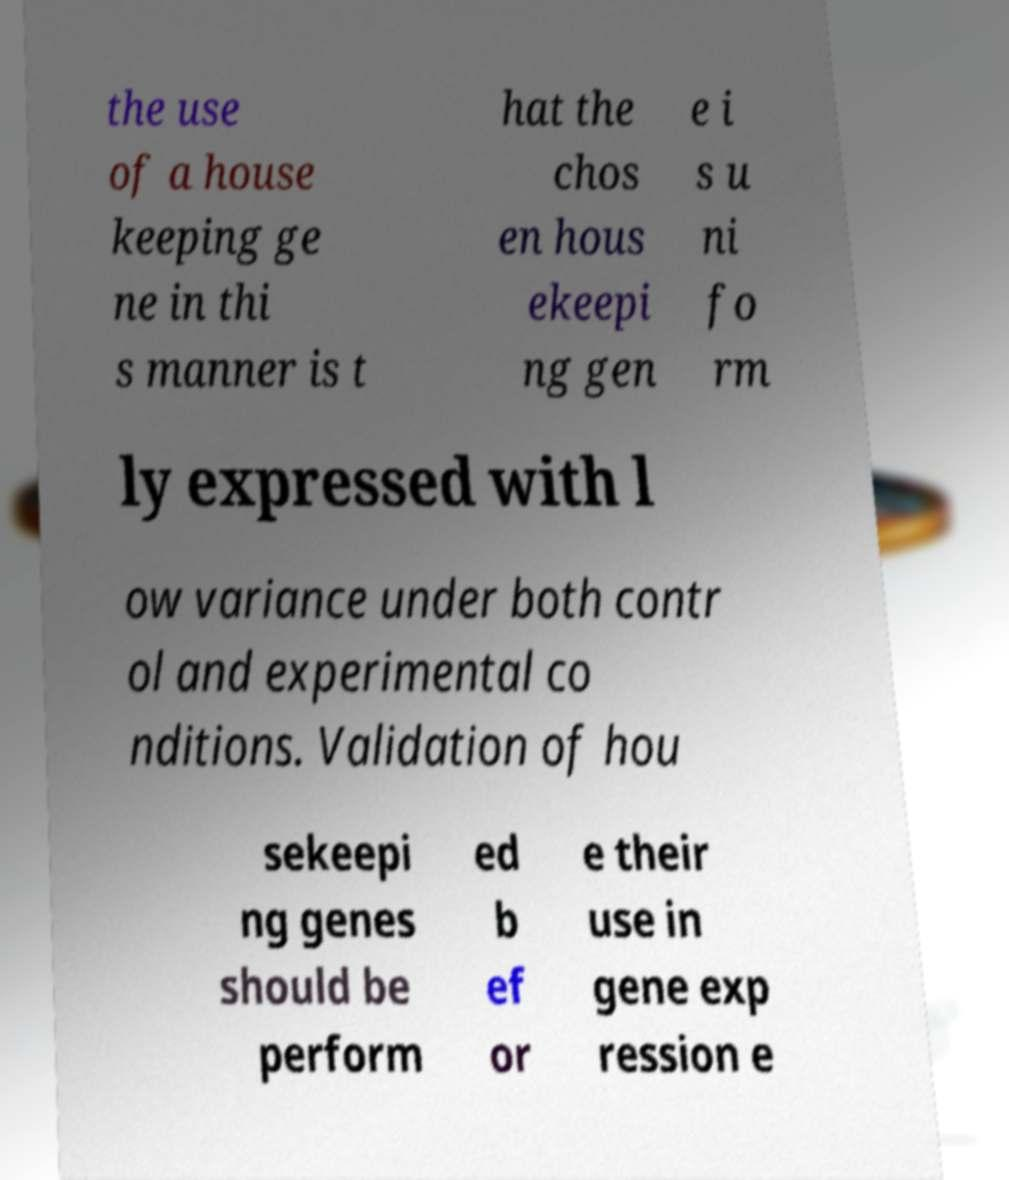Please identify and transcribe the text found in this image. the use of a house keeping ge ne in thi s manner is t hat the chos en hous ekeepi ng gen e i s u ni fo rm ly expressed with l ow variance under both contr ol and experimental co nditions. Validation of hou sekeepi ng genes should be perform ed b ef or e their use in gene exp ression e 